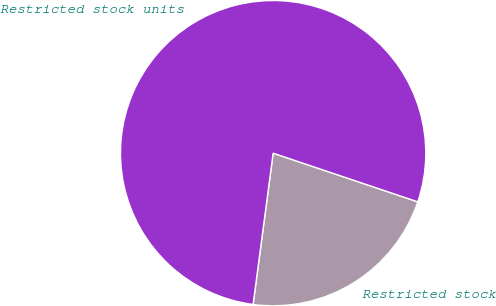Convert chart. <chart><loc_0><loc_0><loc_500><loc_500><pie_chart><fcel>Restricted stock<fcel>Restricted stock units<nl><fcel>21.93%<fcel>78.07%<nl></chart> 